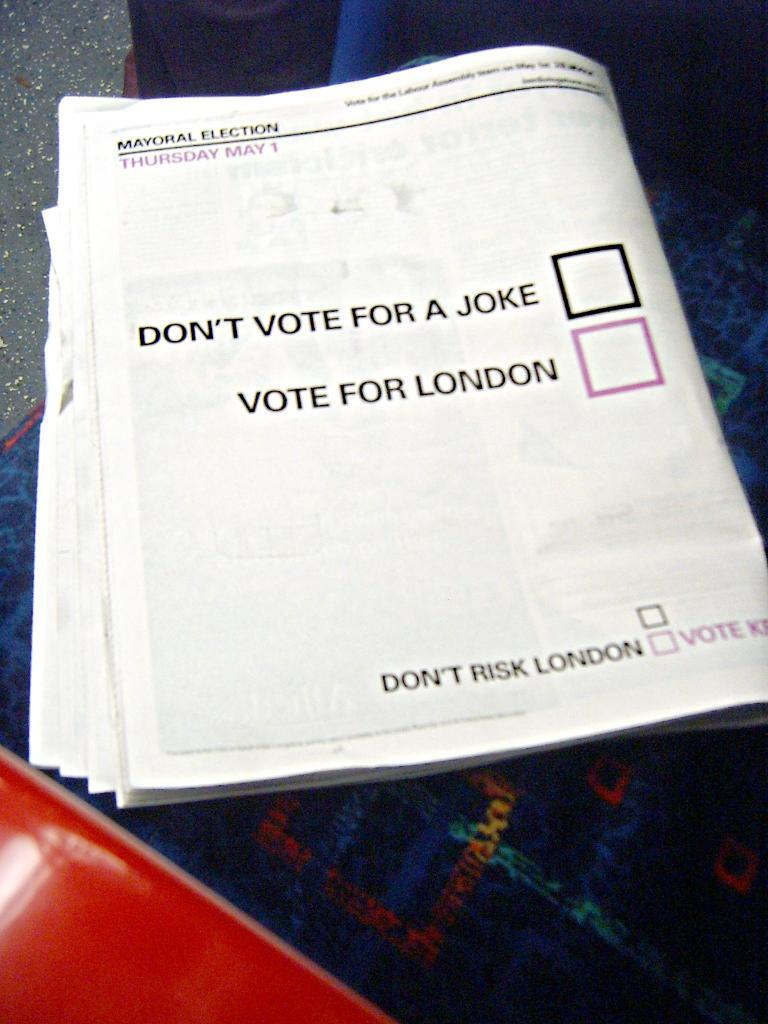<image>
Summarize the visual content of the image. A newspaper has two check boxes asking you to either not vote for a joke or to vote for london. 